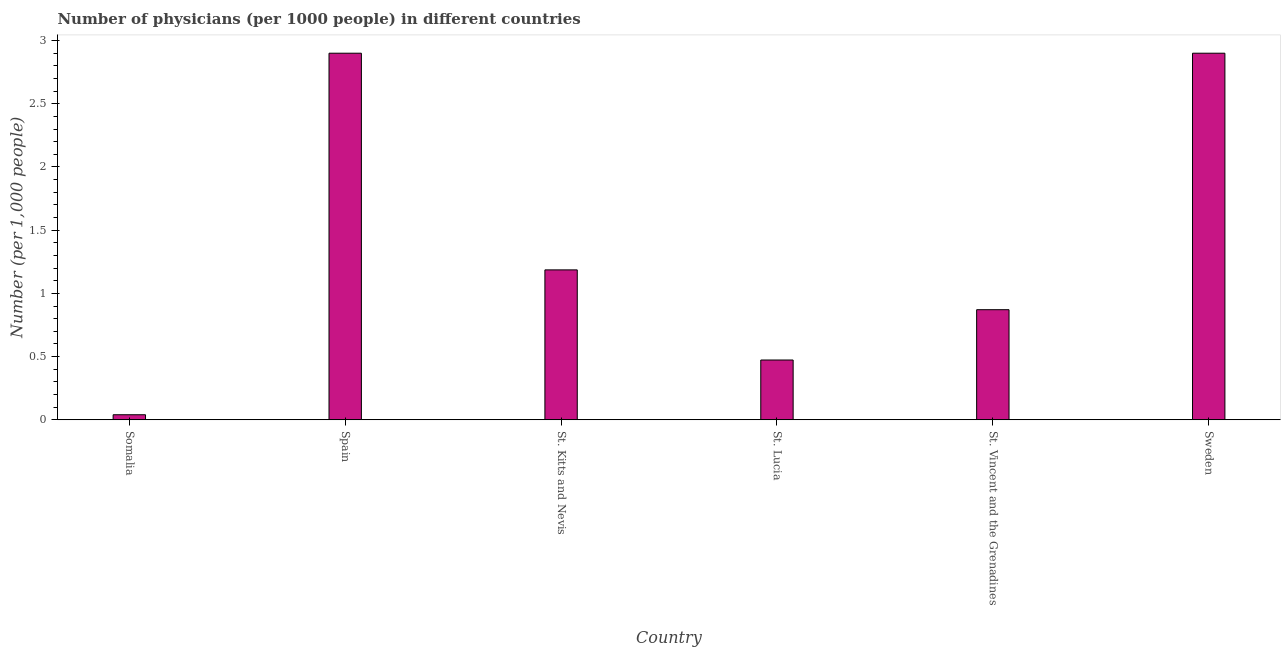Does the graph contain any zero values?
Keep it short and to the point. No. Does the graph contain grids?
Offer a very short reply. No. What is the title of the graph?
Offer a terse response. Number of physicians (per 1000 people) in different countries. What is the label or title of the X-axis?
Provide a succinct answer. Country. What is the label or title of the Y-axis?
Your answer should be compact. Number (per 1,0 people). What is the number of physicians in Somalia?
Provide a succinct answer. 0.04. In which country was the number of physicians minimum?
Make the answer very short. Somalia. What is the sum of the number of physicians?
Keep it short and to the point. 8.37. What is the difference between the number of physicians in Spain and St. Kitts and Nevis?
Provide a succinct answer. 1.71. What is the average number of physicians per country?
Offer a terse response. 1.4. What is the median number of physicians?
Your answer should be very brief. 1.03. In how many countries, is the number of physicians greater than 2.4 ?
Ensure brevity in your answer.  2. What is the difference between the highest and the second highest number of physicians?
Provide a succinct answer. 0. Is the sum of the number of physicians in Somalia and St. Vincent and the Grenadines greater than the maximum number of physicians across all countries?
Keep it short and to the point. No. What is the difference between the highest and the lowest number of physicians?
Ensure brevity in your answer.  2.86. In how many countries, is the number of physicians greater than the average number of physicians taken over all countries?
Provide a succinct answer. 2. What is the Number (per 1,000 people) of St. Kitts and Nevis?
Give a very brief answer. 1.19. What is the Number (per 1,000 people) in St. Lucia?
Ensure brevity in your answer.  0.47. What is the Number (per 1,000 people) in St. Vincent and the Grenadines?
Offer a terse response. 0.87. What is the difference between the Number (per 1,000 people) in Somalia and Spain?
Make the answer very short. -2.86. What is the difference between the Number (per 1,000 people) in Somalia and St. Kitts and Nevis?
Keep it short and to the point. -1.15. What is the difference between the Number (per 1,000 people) in Somalia and St. Lucia?
Provide a succinct answer. -0.43. What is the difference between the Number (per 1,000 people) in Somalia and St. Vincent and the Grenadines?
Offer a terse response. -0.83. What is the difference between the Number (per 1,000 people) in Somalia and Sweden?
Your response must be concise. -2.86. What is the difference between the Number (per 1,000 people) in Spain and St. Kitts and Nevis?
Make the answer very short. 1.71. What is the difference between the Number (per 1,000 people) in Spain and St. Lucia?
Make the answer very short. 2.43. What is the difference between the Number (per 1,000 people) in Spain and St. Vincent and the Grenadines?
Provide a succinct answer. 2.03. What is the difference between the Number (per 1,000 people) in Spain and Sweden?
Provide a succinct answer. 0. What is the difference between the Number (per 1,000 people) in St. Kitts and Nevis and St. Lucia?
Provide a short and direct response. 0.71. What is the difference between the Number (per 1,000 people) in St. Kitts and Nevis and St. Vincent and the Grenadines?
Your response must be concise. 0.32. What is the difference between the Number (per 1,000 people) in St. Kitts and Nevis and Sweden?
Keep it short and to the point. -1.71. What is the difference between the Number (per 1,000 people) in St. Lucia and St. Vincent and the Grenadines?
Your answer should be very brief. -0.4. What is the difference between the Number (per 1,000 people) in St. Lucia and Sweden?
Offer a terse response. -2.43. What is the difference between the Number (per 1,000 people) in St. Vincent and the Grenadines and Sweden?
Your answer should be very brief. -2.03. What is the ratio of the Number (per 1,000 people) in Somalia to that in Spain?
Your response must be concise. 0.01. What is the ratio of the Number (per 1,000 people) in Somalia to that in St. Kitts and Nevis?
Your answer should be very brief. 0.03. What is the ratio of the Number (per 1,000 people) in Somalia to that in St. Lucia?
Make the answer very short. 0.09. What is the ratio of the Number (per 1,000 people) in Somalia to that in St. Vincent and the Grenadines?
Your answer should be very brief. 0.05. What is the ratio of the Number (per 1,000 people) in Somalia to that in Sweden?
Keep it short and to the point. 0.01. What is the ratio of the Number (per 1,000 people) in Spain to that in St. Kitts and Nevis?
Give a very brief answer. 2.44. What is the ratio of the Number (per 1,000 people) in Spain to that in St. Lucia?
Keep it short and to the point. 6.13. What is the ratio of the Number (per 1,000 people) in Spain to that in St. Vincent and the Grenadines?
Ensure brevity in your answer.  3.33. What is the ratio of the Number (per 1,000 people) in Spain to that in Sweden?
Your answer should be very brief. 1. What is the ratio of the Number (per 1,000 people) in St. Kitts and Nevis to that in St. Lucia?
Ensure brevity in your answer.  2.51. What is the ratio of the Number (per 1,000 people) in St. Kitts and Nevis to that in St. Vincent and the Grenadines?
Provide a succinct answer. 1.36. What is the ratio of the Number (per 1,000 people) in St. Kitts and Nevis to that in Sweden?
Your answer should be compact. 0.41. What is the ratio of the Number (per 1,000 people) in St. Lucia to that in St. Vincent and the Grenadines?
Your response must be concise. 0.54. What is the ratio of the Number (per 1,000 people) in St. Lucia to that in Sweden?
Ensure brevity in your answer.  0.16. 